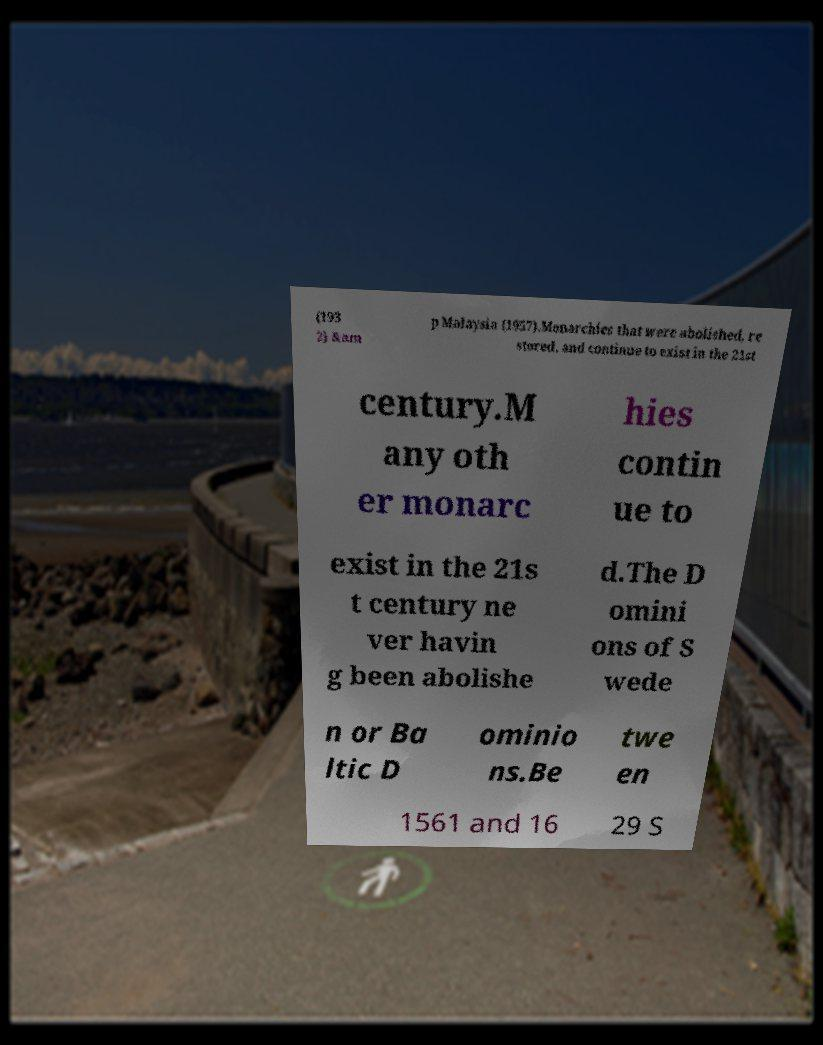There's text embedded in this image that I need extracted. Can you transcribe it verbatim? (193 2) &am p Malaysia (1957).Monarchies that were abolished, re stored, and continue to exist in the 21st century.M any oth er monarc hies contin ue to exist in the 21s t century ne ver havin g been abolishe d.The D omini ons of S wede n or Ba ltic D ominio ns.Be twe en 1561 and 16 29 S 